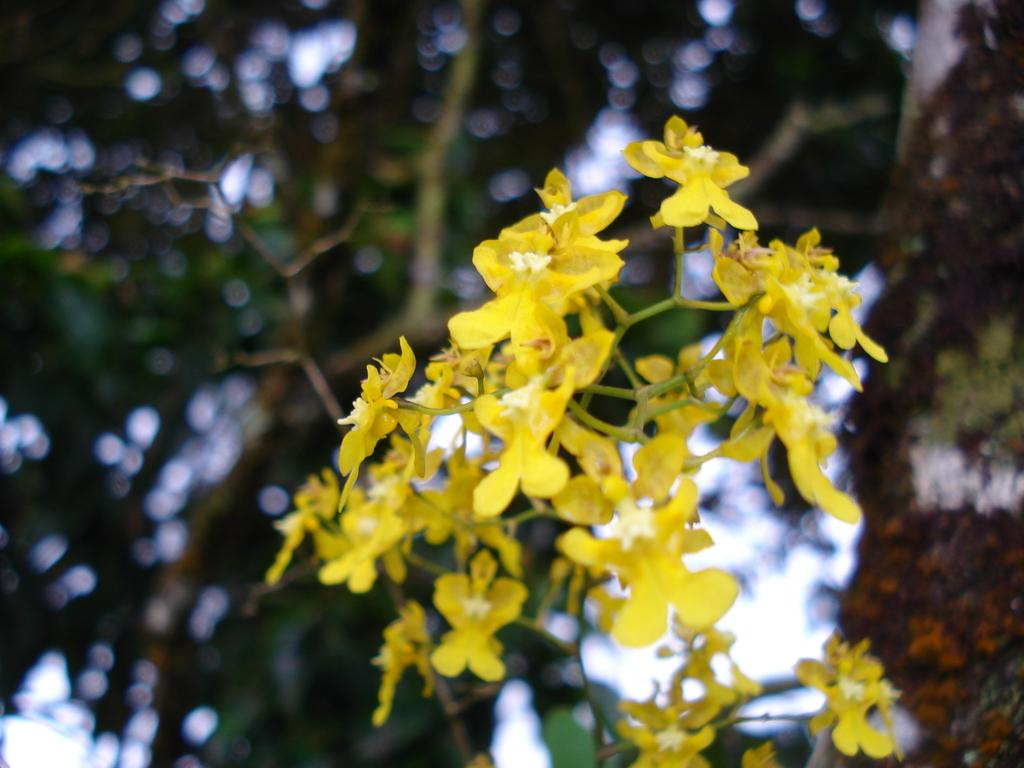What type of plants can be seen in the image? There are flowers in the image. What else can be seen in the image besides flowers? There is a tree with leaves and branches in the image. Can you see a deer playing a drum while riding a cart in the image? No, there is no deer, drum, or cart present in the image. 